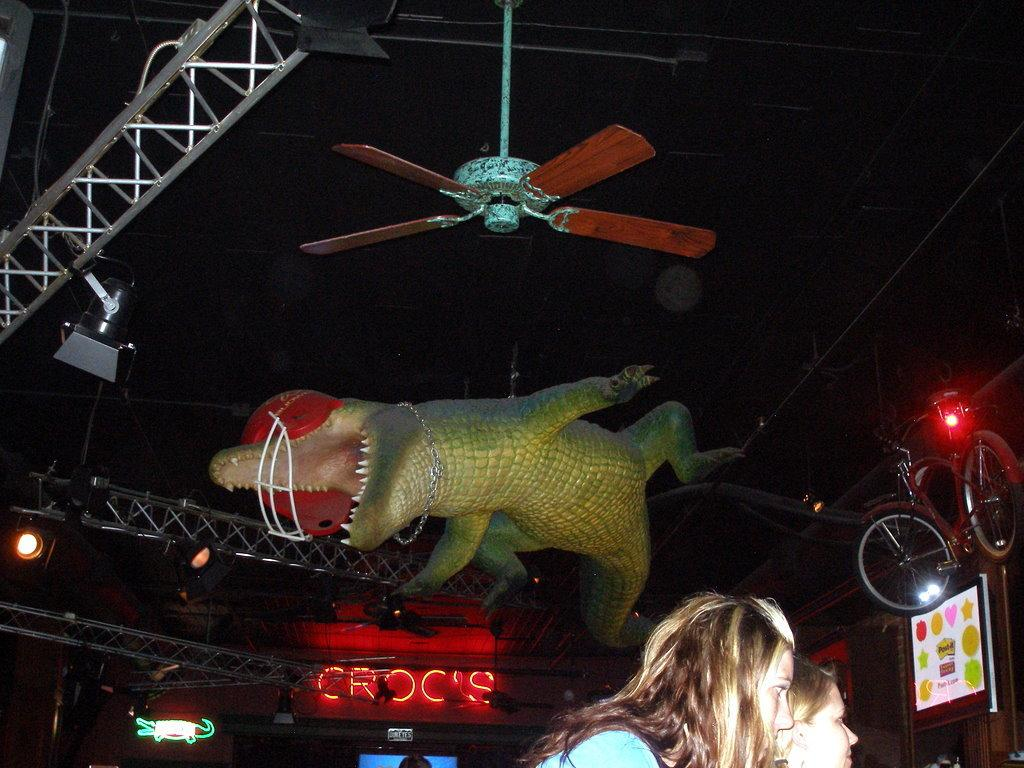What is the main object in the image? There is a statue in the image. What other objects can be seen in the image? There is a fan, lights, a bicycle, and a screen in the image. Are there any people in the image? Yes, there are two persons in the image. What is the color of the background in the image? The background of the image is dark. What type of earth can be seen in the image? There is no earth visible in the image; it is an indoor setting with a statue, fan, lights, bicycle, screen, and two persons. Is there a zipper on any of the objects in the image? There is no zipper present on any of the objects in the image. 